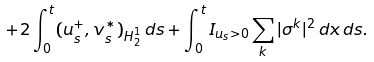<formula> <loc_0><loc_0><loc_500><loc_500>+ 2 \int _ { 0 } ^ { t } ( u ^ { + } _ { s } , v ^ { * } _ { s } ) _ { H ^ { 1 } _ { 2 } } \, d s + \int _ { 0 } ^ { t } I _ { u _ { s } > 0 } \sum _ { k } | \sigma ^ { k } | ^ { 2 } \, d x \, d s .</formula> 